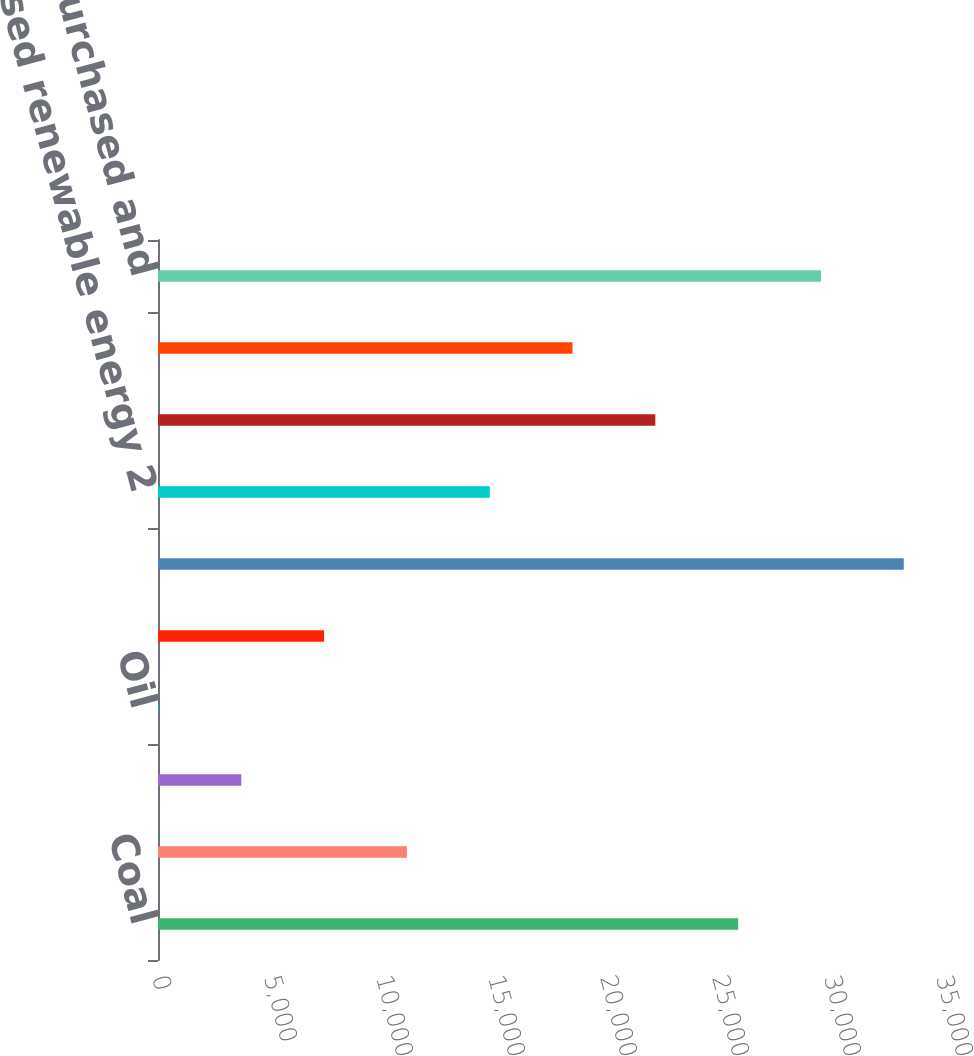Convert chart to OTSL. <chart><loc_0><loc_0><loc_500><loc_500><bar_chart><fcel>Coal<fcel>Gas<fcel>Renewable energy<fcel>Oil<fcel>Net pumped storage 1<fcel>Total owned generation<fcel>Purchased renewable energy 2<fcel>Purchased generation - other 2<fcel>Net interchange power 3<fcel>Total purchased and<nl><fcel>25899.3<fcel>11111.7<fcel>3717.9<fcel>21<fcel>7414.8<fcel>33293.1<fcel>14808.6<fcel>22202.4<fcel>18505.5<fcel>29596.2<nl></chart> 